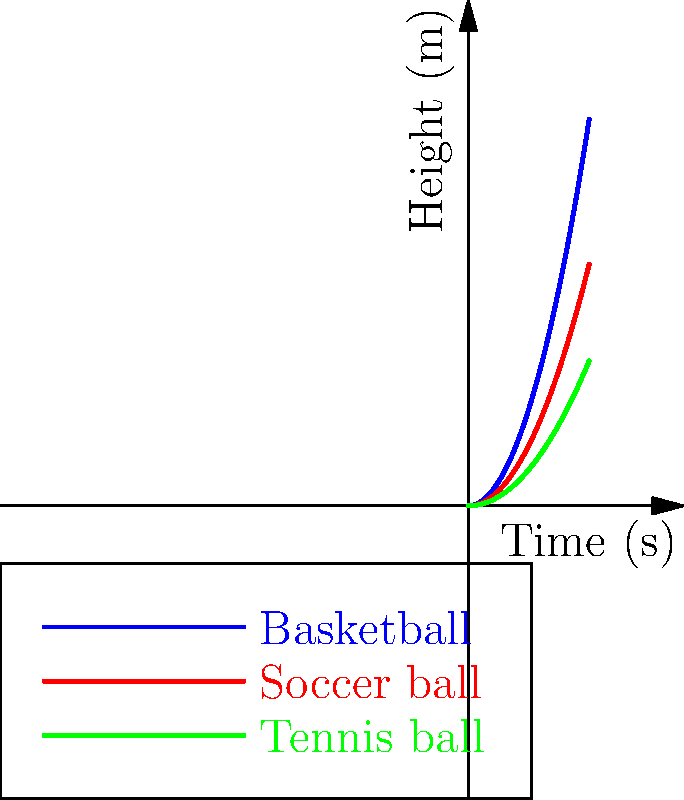In the motion diagram above, three different sports balls are shown bouncing. Based on the curves, which ball has the highest initial velocity when it hits the ground and bounces back up? To determine which ball has the highest initial velocity when it bounces, we need to analyze the slopes of the curves at the point where they start rising (the bounce point). The steeper the slope, the higher the initial velocity. Let's break it down step-by-step:

1. The curves represent the height of each ball over time.
2. The point where each curve touches the x-axis (time axis) represents the moment of impact with the ground.
3. The steepness of the curve immediately after this point indicates the initial velocity of the ball as it bounces back up.
4. Looking at the diagram:
   - The blue curve (Basketball) has the steepest slope at the bounce point.
   - The red curve (Soccer ball) has a moderate slope.
   - The green curve (Tennis ball) has the gentlest slope.
5. The steeper the slope, the faster the ball is moving upward immediately after the bounce.
6. Therefore, the ball with the steepest slope at the bounce point has the highest initial velocity.

In this case, the blue curve representing the basketball has the steepest slope at the bounce point, indicating that it has the highest initial velocity when it bounces back up.
Answer: Basketball 